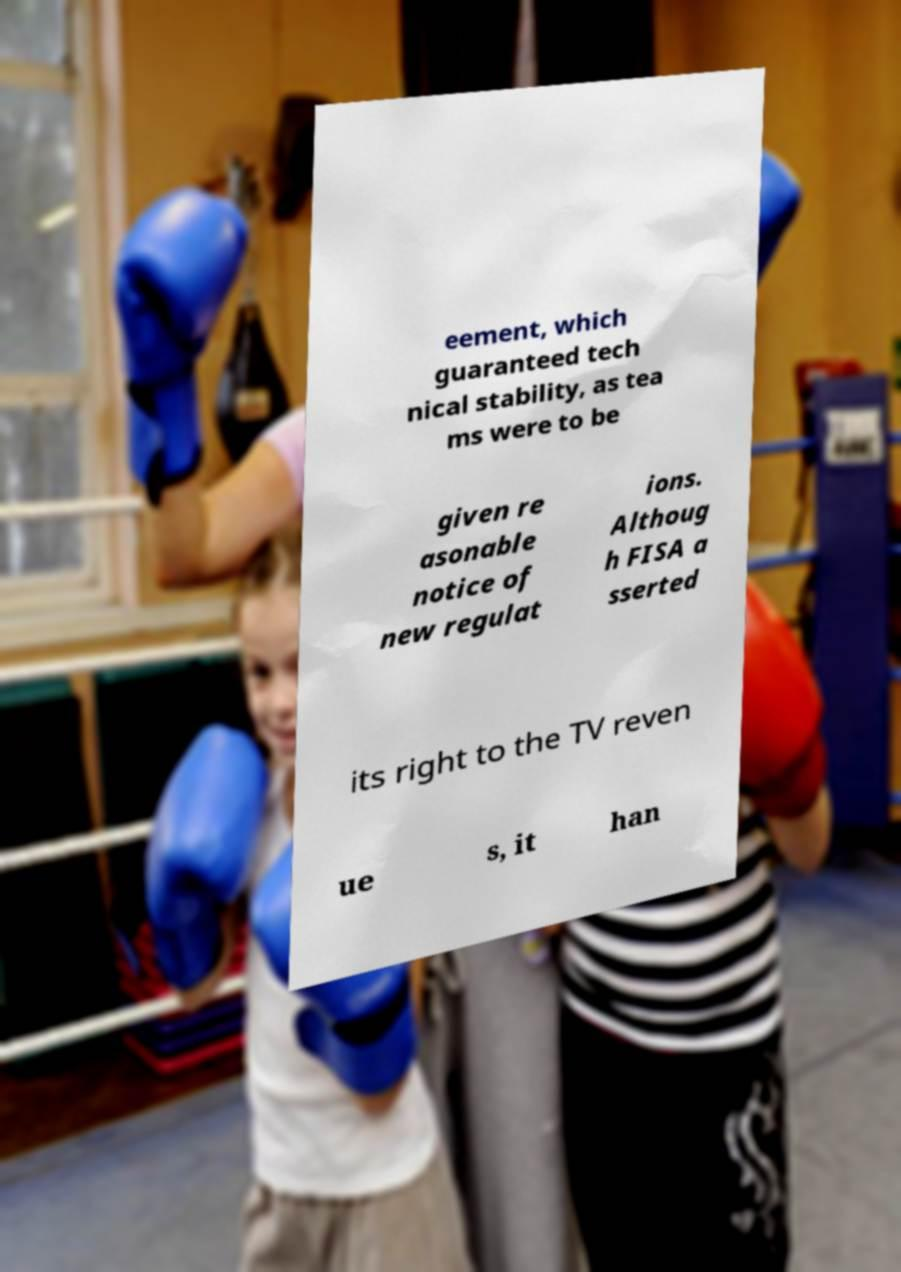Please read and relay the text visible in this image. What does it say? eement, which guaranteed tech nical stability, as tea ms were to be given re asonable notice of new regulat ions. Althoug h FISA a sserted its right to the TV reven ue s, it han 